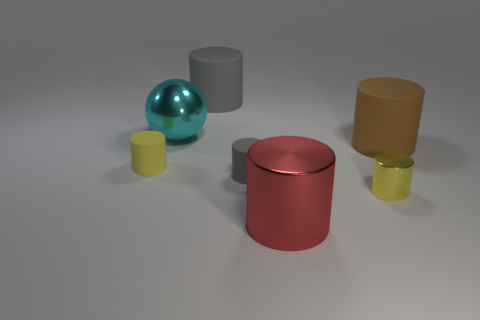Are there fewer large shiny spheres than gray rubber objects?
Your answer should be compact. Yes. The large thing that is to the left of the gray matte thing behind the small matte cylinder that is to the left of the large cyan metal object is what shape?
Ensure brevity in your answer.  Sphere. Are there any red metallic cylinders?
Ensure brevity in your answer.  Yes. There is a brown rubber thing; does it have the same size as the gray matte thing that is behind the cyan ball?
Provide a short and direct response. Yes. Is there a red thing right of the big thing behind the large sphere?
Make the answer very short. Yes. There is a object that is both right of the red metallic object and in front of the large brown thing; what material is it?
Your response must be concise. Metal. What color is the large matte cylinder on the right side of the large matte cylinder that is behind the big rubber cylinder that is to the right of the large gray rubber object?
Your response must be concise. Brown. The other rubber cylinder that is the same size as the brown cylinder is what color?
Give a very brief answer. Gray. Do the sphere and the small object in front of the small gray cylinder have the same color?
Your answer should be very brief. No. What is the big gray cylinder to the right of the big metal thing that is behind the big brown matte cylinder made of?
Make the answer very short. Rubber. 